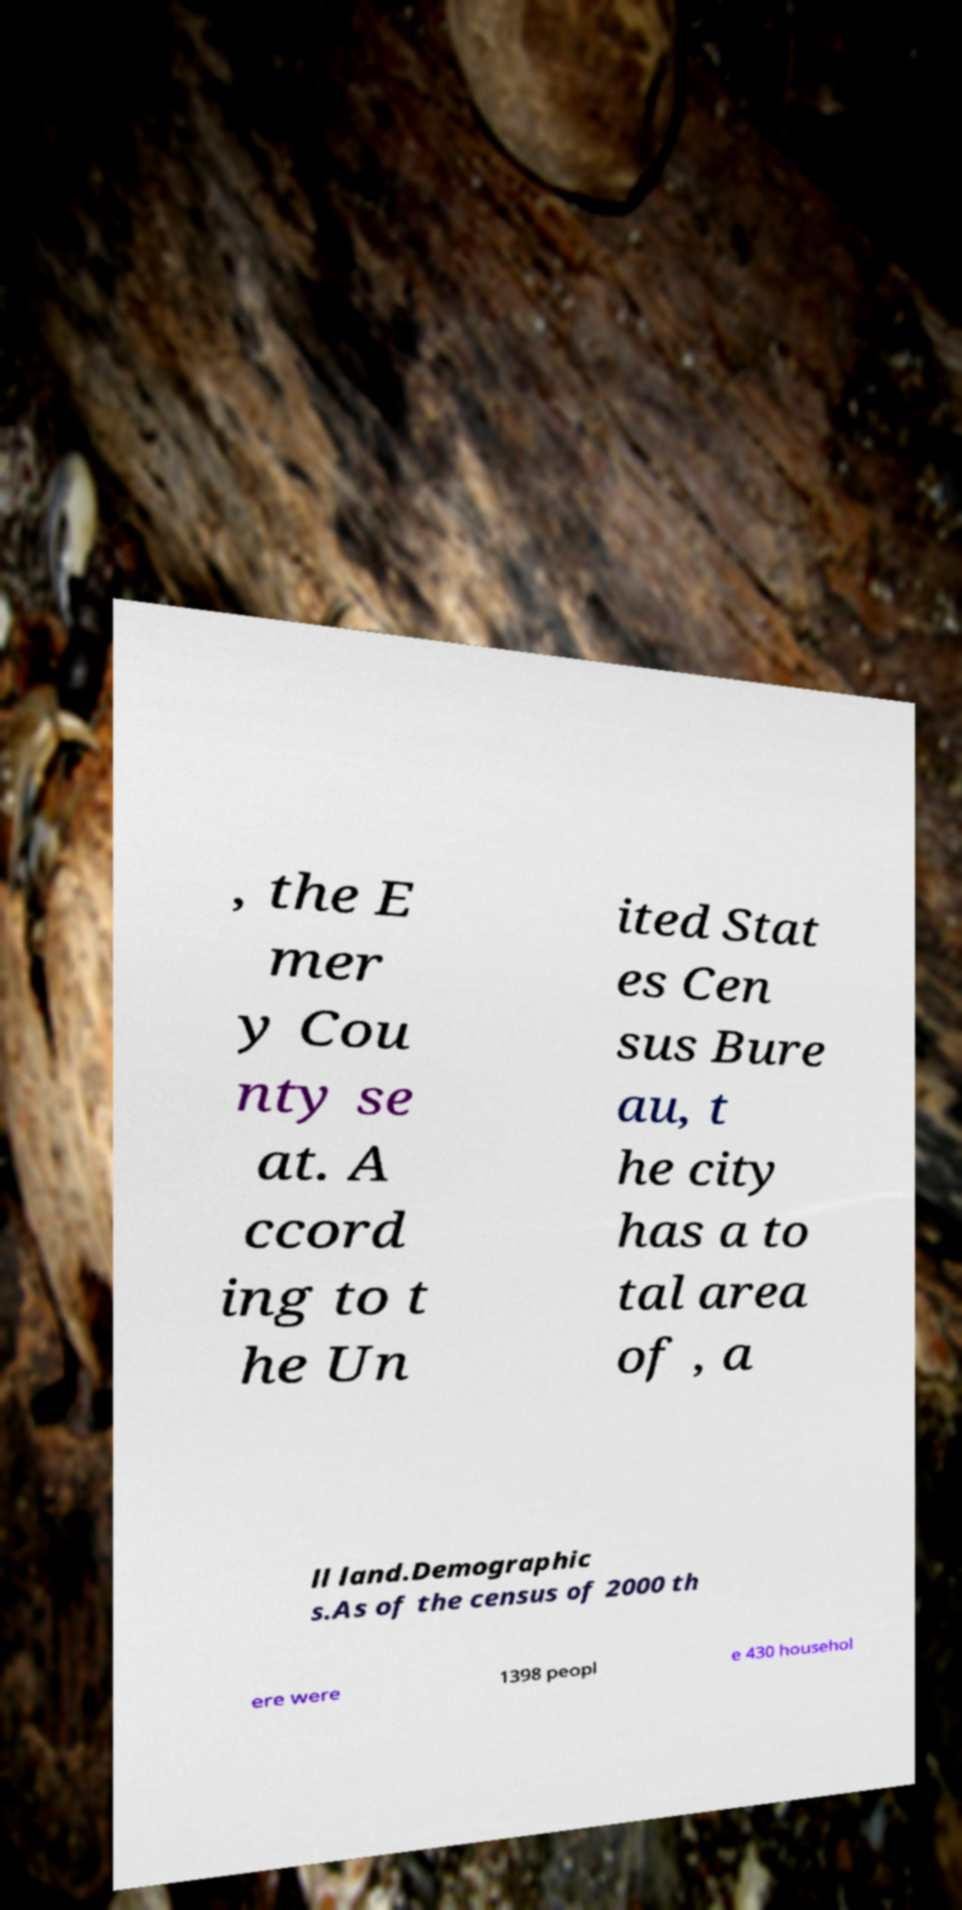Could you extract and type out the text from this image? , the E mer y Cou nty se at. A ccord ing to t he Un ited Stat es Cen sus Bure au, t he city has a to tal area of , a ll land.Demographic s.As of the census of 2000 th ere were 1398 peopl e 430 househol 